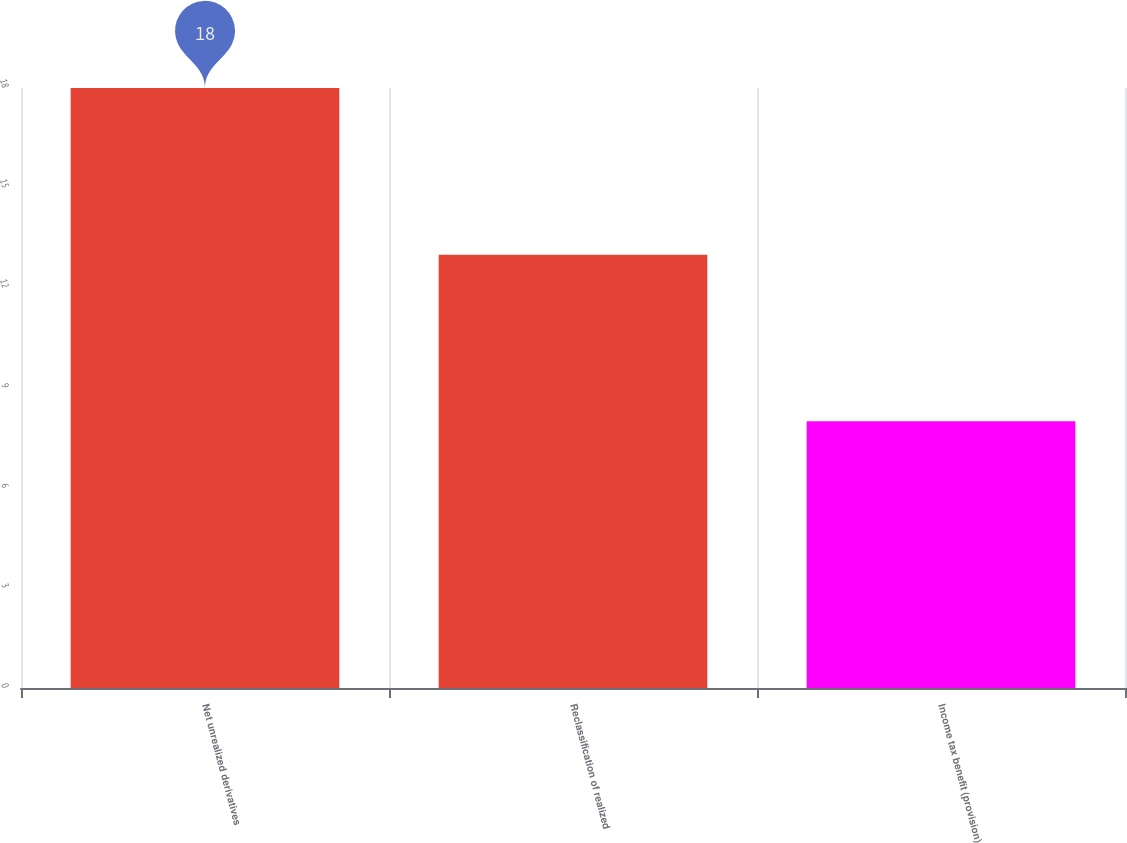<chart> <loc_0><loc_0><loc_500><loc_500><bar_chart><fcel>Net unrealized derivatives<fcel>Reclassification of realized<fcel>Income tax benefit (provision)<nl><fcel>18<fcel>13<fcel>8<nl></chart> 